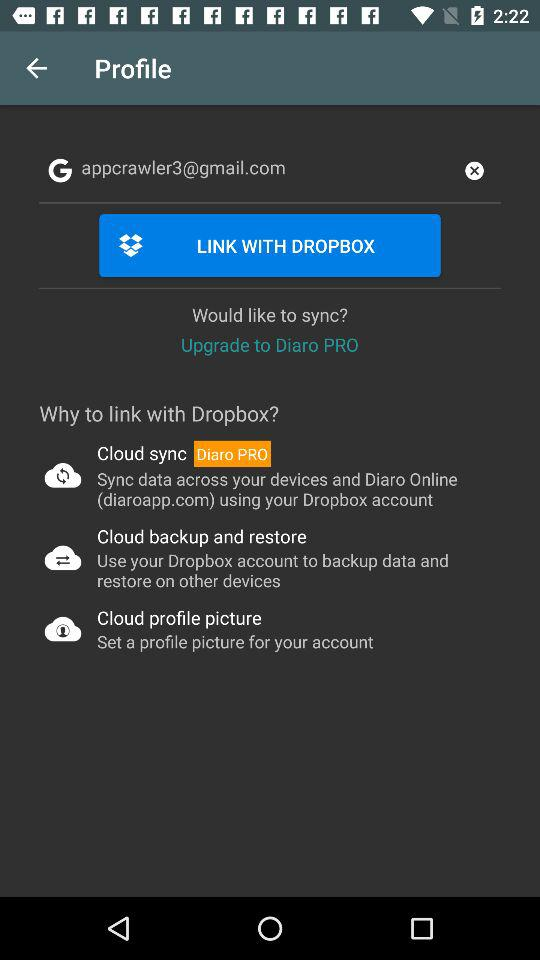What is the email address? The email address is appcrawler3@gmail.com. 